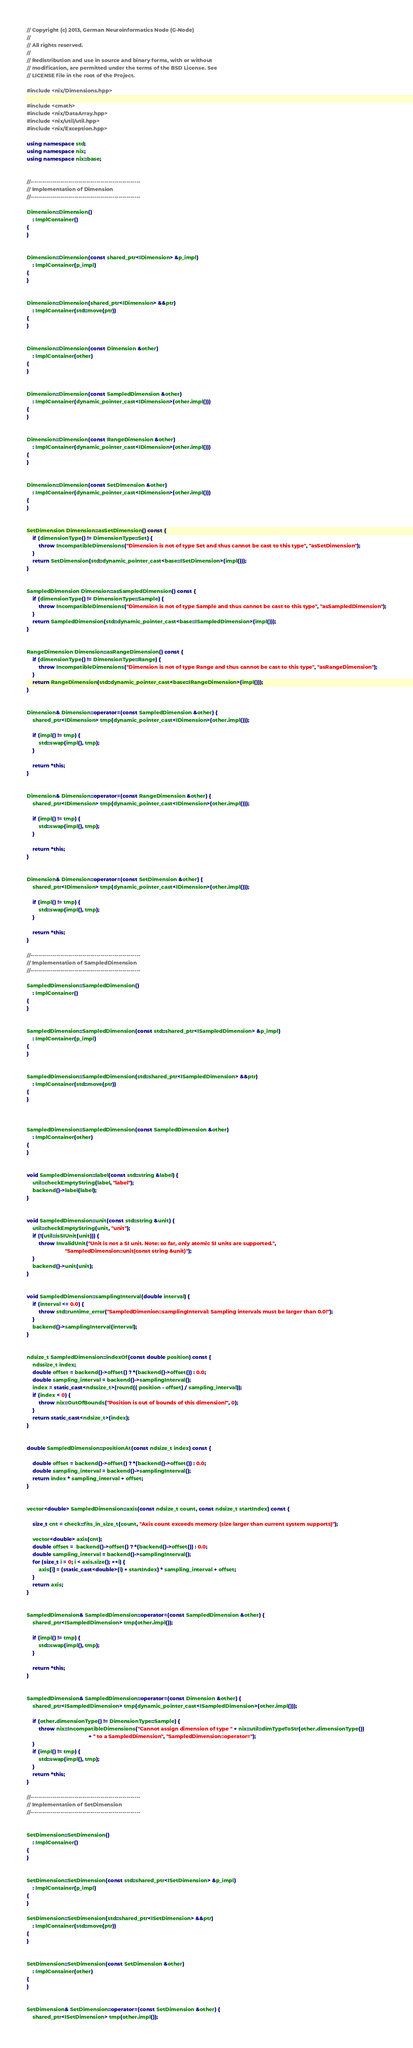<code> <loc_0><loc_0><loc_500><loc_500><_C++_>// Copyright (c) 2013, German Neuroinformatics Node (G-Node)
//
// All rights reserved.
//
// Redistribution and use in source and binary forms, with or without
// modification, are permitted under the terms of the BSD License. See
// LICENSE file in the root of the Project.

#include <nix/Dimensions.hpp>

#include <cmath>
#include <nix/DataArray.hpp>
#include <nix/util/util.hpp>
#include <nix/Exception.hpp>

using namespace std;
using namespace nix;
using namespace nix::base;


//-------------------------------------------------------
// Implementation of Dimension
//-------------------------------------------------------

Dimension::Dimension()
    : ImplContainer()
{
}


Dimension::Dimension(const shared_ptr<IDimension> &p_impl)
    : ImplContainer(p_impl)
{
}


Dimension::Dimension(shared_ptr<IDimension> &&ptr)
    : ImplContainer(std::move(ptr))
{
}


Dimension::Dimension(const Dimension &other)
    : ImplContainer(other)
{
}


Dimension::Dimension(const SampledDimension &other)
    : ImplContainer(dynamic_pointer_cast<IDimension>(other.impl()))
{
}


Dimension::Dimension(const RangeDimension &other)
    : ImplContainer(dynamic_pointer_cast<IDimension>(other.impl()))
{
}


Dimension::Dimension(const SetDimension &other)
    : ImplContainer(dynamic_pointer_cast<IDimension>(other.impl()))
{
}


SetDimension Dimension::asSetDimension() const {
    if (dimensionType() != DimensionType::Set) {
        throw IncompatibleDimensions("Dimension is not of type Set and thus cannot be cast to this type", "asSetDimension");
    }
    return SetDimension(std::dynamic_pointer_cast<base::ISetDimension>(impl()));
}


SampledDimension Dimension::asSampledDimension() const {
    if (dimensionType() != DimensionType::Sample) {
        throw IncompatibleDimensions("Dimension is not of type Sample and thus cannot be cast to this type", "asSampledDimension");
    }
    return SampledDimension(std::dynamic_pointer_cast<base::ISampledDimension>(impl()));
}


RangeDimension Dimension::asRangeDimension() const {
    if (dimensionType() != DimensionType::Range) {
        throw IncompatibleDimensions("Dimension is not of type Range and thus cannot be cast to this type", "asRangeDimension");
    }
    return RangeDimension(std::dynamic_pointer_cast<base::IRangeDimension>(impl()));
}


Dimension& Dimension::operator=(const SampledDimension &other) {
    shared_ptr<IDimension> tmp(dynamic_pointer_cast<IDimension>(other.impl()));

    if (impl() != tmp) {
        std::swap(impl(), tmp);
    }

    return *this;
}


Dimension& Dimension::operator=(const RangeDimension &other) {
    shared_ptr<IDimension> tmp(dynamic_pointer_cast<IDimension>(other.impl()));

    if (impl() != tmp) {
        std::swap(impl(), tmp);
    }

    return *this;
}


Dimension& Dimension::operator=(const SetDimension &other) {
    shared_ptr<IDimension> tmp(dynamic_pointer_cast<IDimension>(other.impl()));

    if (impl() != tmp) {
        std::swap(impl(), tmp);
    }

    return *this;
}

//-------------------------------------------------------
// Implementation of SampledDimension
//-------------------------------------------------------

SampledDimension::SampledDimension()
    : ImplContainer()
{
}


SampledDimension::SampledDimension(const std::shared_ptr<ISampledDimension> &p_impl)
    : ImplContainer(p_impl)
{
}


SampledDimension::SampledDimension(std::shared_ptr<ISampledDimension> &&ptr)
    : ImplContainer(std::move(ptr))
{
}



SampledDimension::SampledDimension(const SampledDimension &other)
    : ImplContainer(other)
{
}


void SampledDimension::label(const std::string &label) {
    util::checkEmptyString(label, "label");
    backend()->label(label);
}


void SampledDimension::unit(const std::string &unit) {
    util::checkEmptyString(unit, "unit");
    if (!(util::isSIUnit(unit))) {
        throw InvalidUnit("Unit is not a SI unit. Note: so far, only atomic SI units are supported.",
                          "SampledDimension::unit(const string &unit)");
    }
    backend()->unit(unit);
}


void SampledDimension::samplingInterval(double interval) {
    if (interval <= 0.0) {
        throw std::runtime_error("SampledDimenion::samplingInterval: Sampling intervals must be larger than 0.0!");
    }
    backend()->samplingInterval(interval);
}


ndsize_t SampledDimension::indexOf(const double position) const {
    ndssize_t index;
    double offset = backend()->offset() ? *(backend()->offset()) : 0.0;
    double sampling_interval = backend()->samplingInterval();
    index = static_cast<ndssize_t>(round(( position - offset) / sampling_interval));
    if (index < 0) {
        throw nix::OutOfBounds("Position is out of bounds of this dimension!", 0);
    }
    return static_cast<ndsize_t>(index);
}


double SampledDimension::positionAt(const ndsize_t index) const {

    double offset = backend()->offset() ? *(backend()->offset()) : 0.0;
    double sampling_interval = backend()->samplingInterval();
    return index * sampling_interval + offset;
}


vector<double> SampledDimension::axis(const ndsize_t count, const ndsize_t startIndex) const {

    size_t cnt = check::fits_in_size_t(count, "Axis count exceeds memory (size larger than current system supports)");

    vector<double> axis(cnt);
    double offset =  backend()->offset() ? *(backend()->offset()) : 0.0;
    double sampling_interval = backend()->samplingInterval();
    for (size_t i = 0; i < axis.size(); ++i) {
        axis[i] = (static_cast<double>(i) + startIndex) * sampling_interval + offset;
    }
    return axis;
}


SampledDimension& SampledDimension::operator=(const SampledDimension &other) {
    shared_ptr<ISampledDimension> tmp(other.impl());

    if (impl() != tmp) {
        std::swap(impl(), tmp);
    }

    return *this;
}


SampledDimension& SampledDimension::operator=(const Dimension &other) {
    shared_ptr<ISampledDimension> tmp(dynamic_pointer_cast<ISampledDimension>(other.impl()));

    if (other.dimensionType() != DimensionType::Sample) {
        throw nix::IncompatibleDimensions("Cannot assign dimension of type " + nix::util::dimTypeToStr(other.dimensionType())
                                          + " to a SampledDimension", "SampledDimension::operator=");
    }
    if (impl() != tmp) {
        std::swap(impl(), tmp);
    }
    return *this;
}

//-------------------------------------------------------
// Implementation of SetDimension
//-------------------------------------------------------


SetDimension::SetDimension()
    : ImplContainer()
{
}


SetDimension::SetDimension(const std::shared_ptr<ISetDimension> &p_impl)
    : ImplContainer(p_impl)
{
}

SetDimension::SetDimension(std::shared_ptr<ISetDimension> &&ptr)
    : ImplContainer(std::move(ptr))
{
}


SetDimension::SetDimension(const SetDimension &other)
    : ImplContainer(other)
{
}


SetDimension& SetDimension::operator=(const SetDimension &other) {
    shared_ptr<ISetDimension> tmp(other.impl());
</code> 